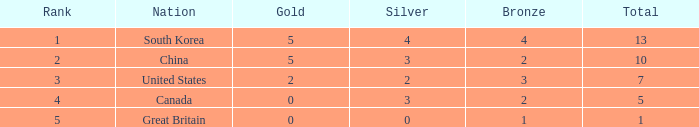What is the total number of Gold, when Silver is 2, and when Total is less than 7? 0.0. 